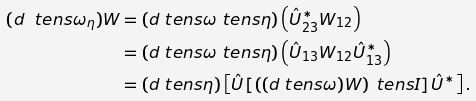Convert formula to latex. <formula><loc_0><loc_0><loc_500><loc_500>( \i d \ t e n s \omega _ { \eta } ) W & = ( \i d \ t e n s \omega \ t e n s \eta ) \left ( \hat { U } _ { 2 3 } ^ { * } W _ { 1 2 } \right ) \\ & = ( \i d \ t e n s \omega \ t e n s \eta ) \left ( \hat { U } _ { 1 3 } W _ { 1 2 } \hat { U } _ { 1 3 } ^ { * } \right ) \\ & = ( \i d \ t e n s \eta ) \left [ \hat { U } \left [ \left ( ( \i d \ t e n s \omega ) W \right ) \ t e n s { I } \right ] \hat { U } ^ { * } \right ] .</formula> 